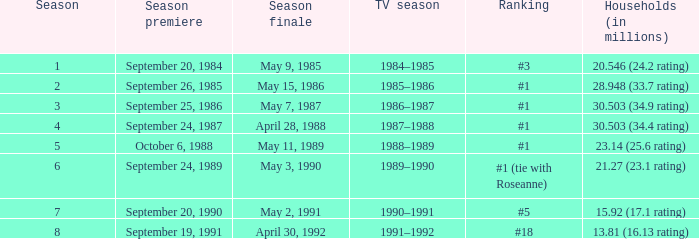9 rating)? 1986–1987. 